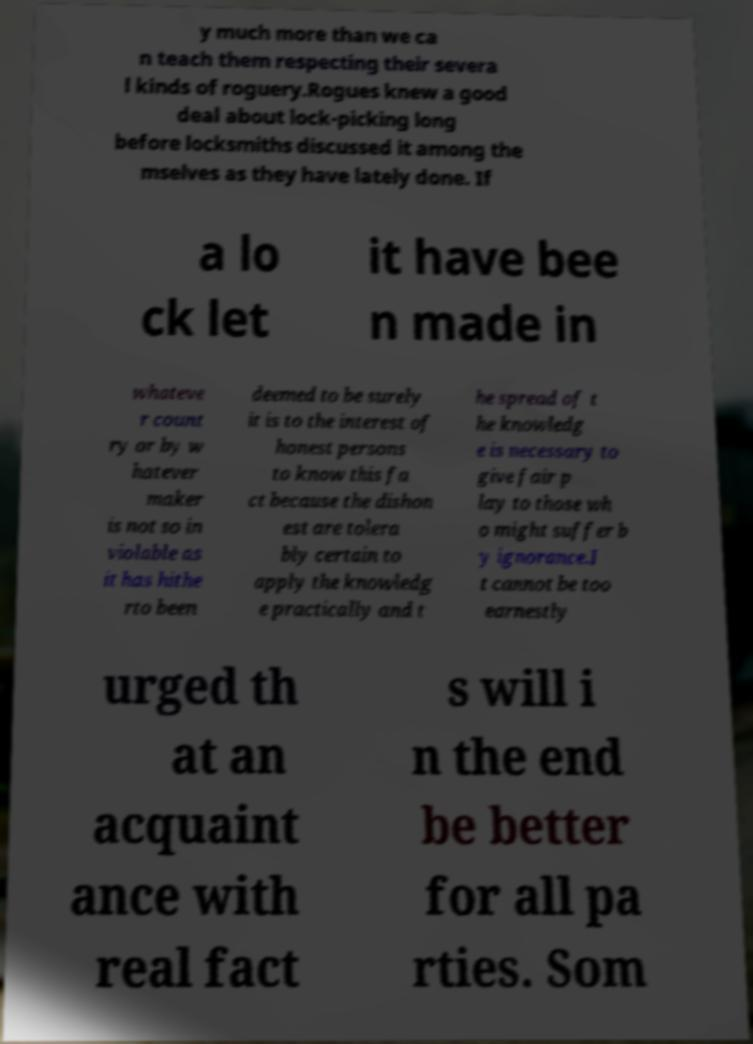Please read and relay the text visible in this image. What does it say? y much more than we ca n teach them respecting their severa l kinds of roguery.Rogues knew a good deal about lock-picking long before locksmiths discussed it among the mselves as they have lately done. If a lo ck let it have bee n made in whateve r count ry or by w hatever maker is not so in violable as it has hithe rto been deemed to be surely it is to the interest of honest persons to know this fa ct because the dishon est are tolera bly certain to apply the knowledg e practically and t he spread of t he knowledg e is necessary to give fair p lay to those wh o might suffer b y ignorance.I t cannot be too earnestly urged th at an acquaint ance with real fact s will i n the end be better for all pa rties. Som 